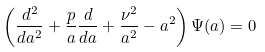Convert formula to latex. <formula><loc_0><loc_0><loc_500><loc_500>\left ( \frac { d ^ { 2 } } { d a ^ { 2 } } + \frac { p } { a } \frac { d } { d a } + \frac { \nu ^ { 2 } } { a ^ { 2 } } - a ^ { 2 } \right ) \Psi ( a ) = 0</formula> 